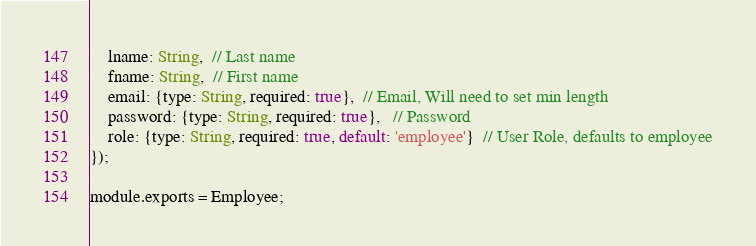<code> <loc_0><loc_0><loc_500><loc_500><_JavaScript_>    lname: String,  // Last name
    fname: String,  // First name
    email: {type: String, required: true},  // Email, Will need to set min length
    password: {type: String, required: true},   // Password
    role: {type: String, required: true, default: 'employee'}  // User Role, defaults to employee
});

module.exports = Employee;</code> 